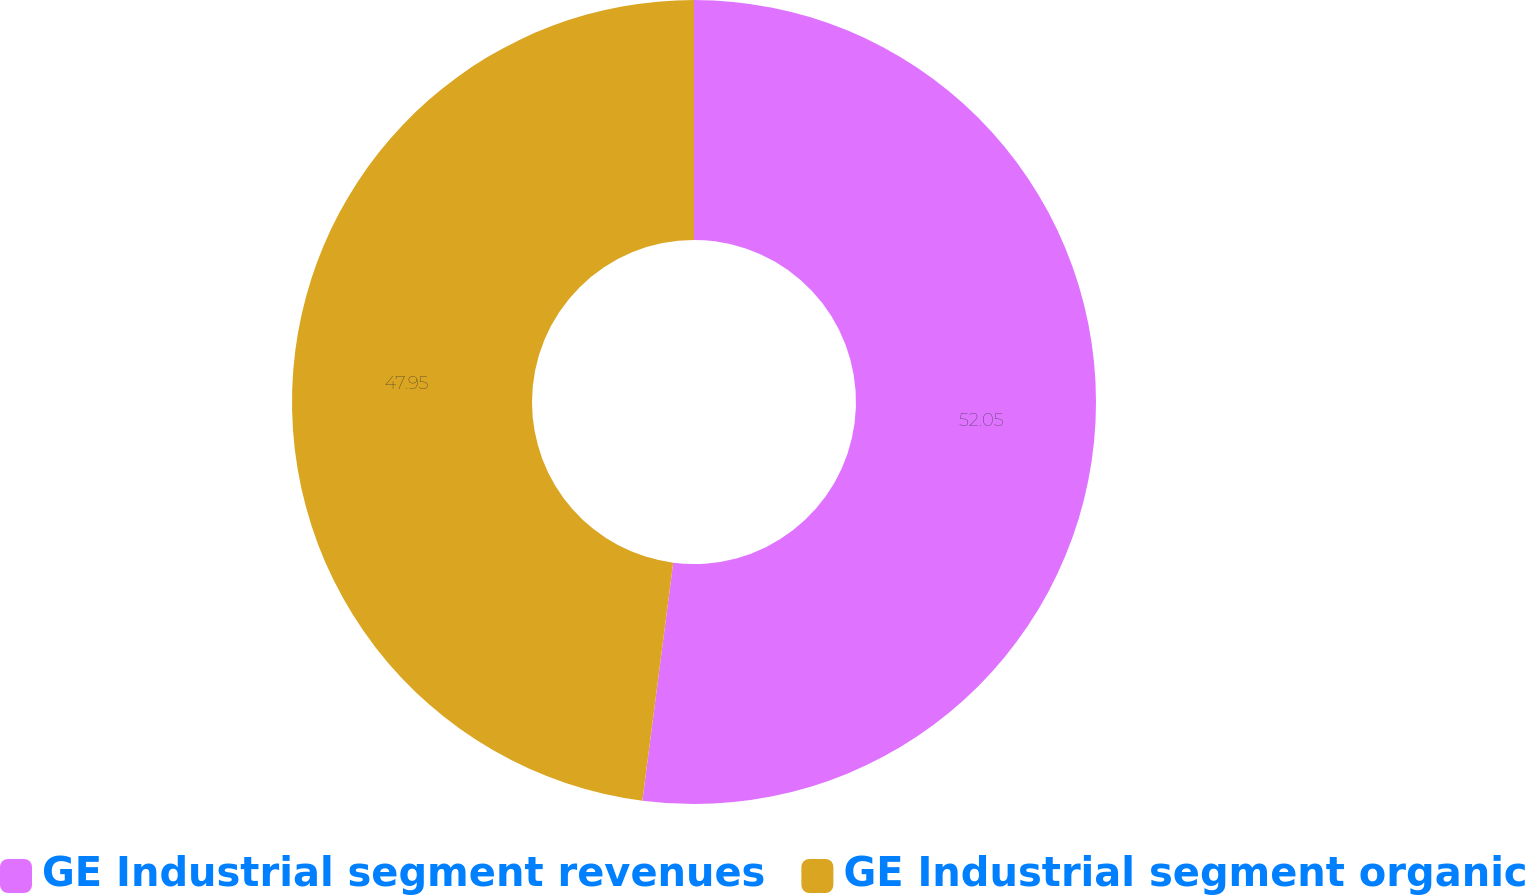Convert chart. <chart><loc_0><loc_0><loc_500><loc_500><pie_chart><fcel>GE Industrial segment revenues<fcel>GE Industrial segment organic<nl><fcel>52.05%<fcel>47.95%<nl></chart> 